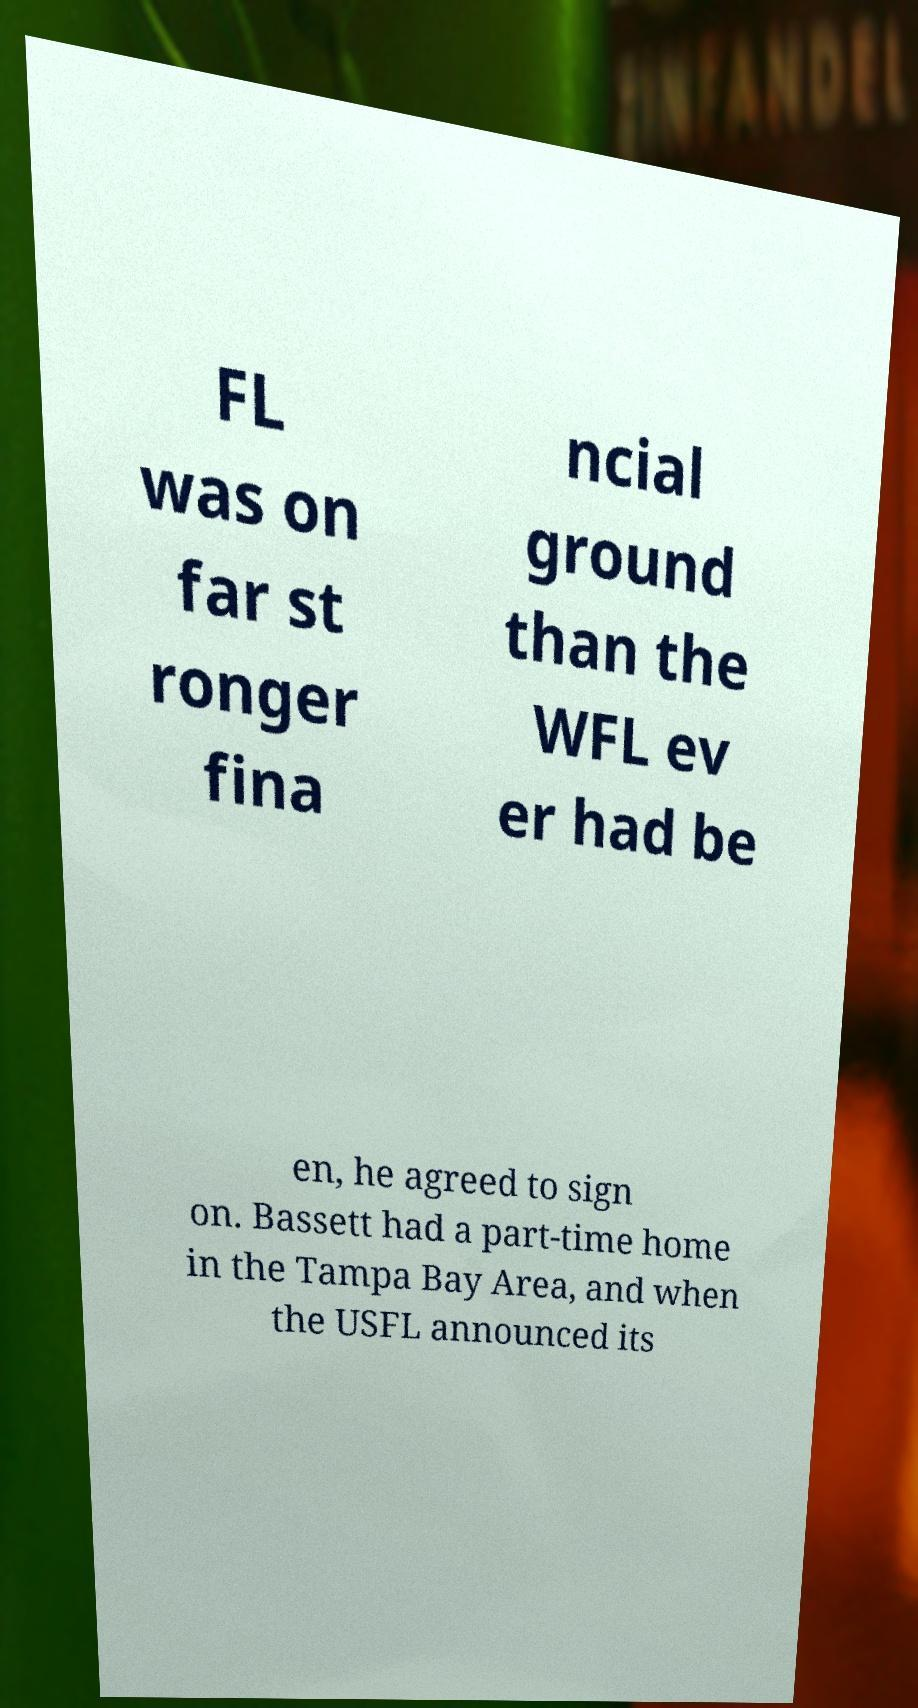Please read and relay the text visible in this image. What does it say? FL was on far st ronger fina ncial ground than the WFL ev er had be en, he agreed to sign on. Bassett had a part-time home in the Tampa Bay Area, and when the USFL announced its 